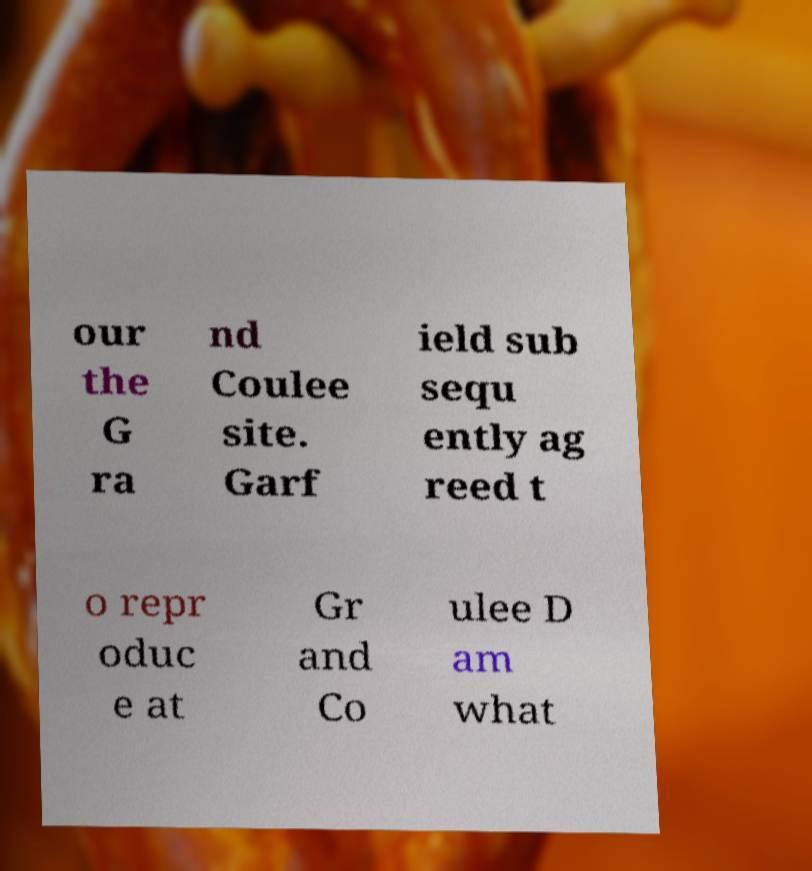I need the written content from this picture converted into text. Can you do that? our the G ra nd Coulee site. Garf ield sub sequ ently ag reed t o repr oduc e at Gr and Co ulee D am what 